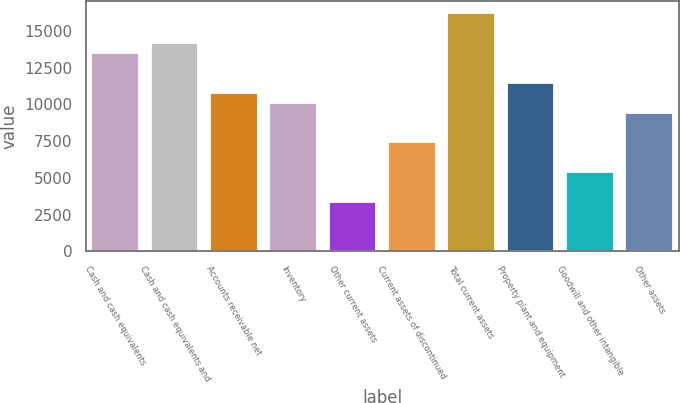<chart> <loc_0><loc_0><loc_500><loc_500><bar_chart><fcel>Cash and cash equivalents<fcel>Cash and cash equivalents and<fcel>Accounts receivable net<fcel>Inventory<fcel>Other current assets<fcel>Current assets of discontinued<fcel>Total current assets<fcel>Property plant and equipment<fcel>Goodwill and other intangible<fcel>Other assets<nl><fcel>13497<fcel>14171.6<fcel>10798.6<fcel>10124<fcel>3378<fcel>7425.6<fcel>16195.4<fcel>11473.2<fcel>5401.8<fcel>9449.4<nl></chart> 